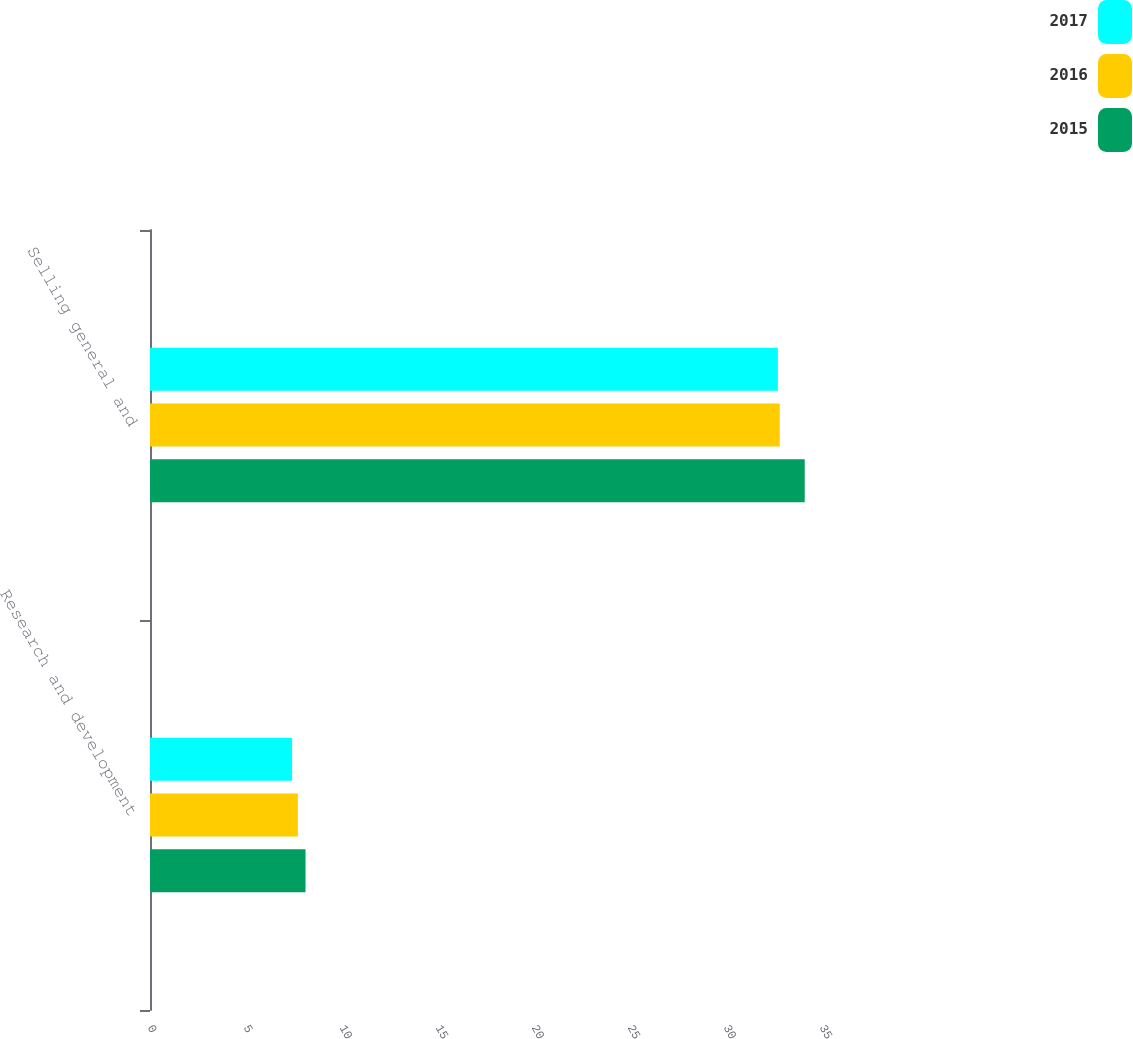<chart> <loc_0><loc_0><loc_500><loc_500><stacked_bar_chart><ecel><fcel>Research and development<fcel>Selling general and<nl><fcel>2017<fcel>7.4<fcel>32.7<nl><fcel>2016<fcel>7.7<fcel>32.8<nl><fcel>2015<fcel>8.1<fcel>34.1<nl></chart> 